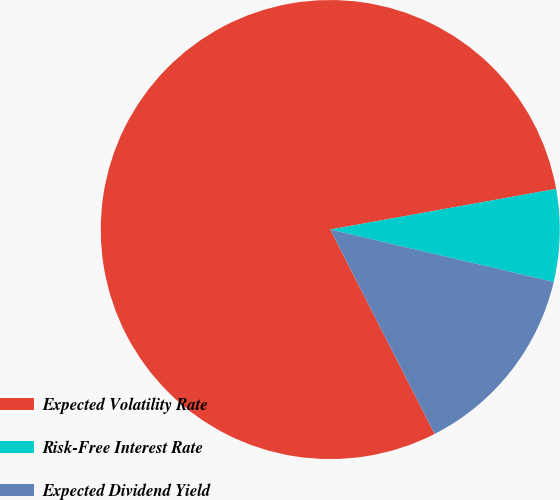Convert chart. <chart><loc_0><loc_0><loc_500><loc_500><pie_chart><fcel>Expected Volatility Rate<fcel>Risk-Free Interest Rate<fcel>Expected Dividend Yield<nl><fcel>79.69%<fcel>6.5%<fcel>13.82%<nl></chart> 